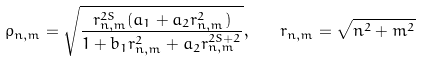Convert formula to latex. <formula><loc_0><loc_0><loc_500><loc_500>\rho _ { n , m } = \sqrt { \frac { r _ { n , m } ^ { 2 S } ( a _ { 1 } + a _ { 2 } r _ { n , m } ^ { 2 } ) } { 1 + b _ { 1 } r _ { n , m } ^ { 2 } + a _ { 2 } r _ { n , m } ^ { 2 S + 2 } } } , \quad r _ { n , m } = \sqrt { n ^ { 2 } + m ^ { 2 } }</formula> 